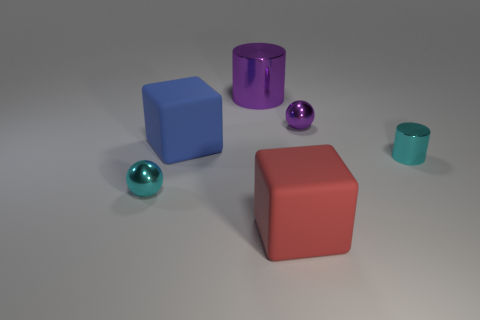There is a small shiny ball behind the cyan ball; is it the same color as the large shiny cylinder?
Your answer should be compact. Yes. There is a small metal cylinder; does it have the same color as the metal thing that is left of the big blue rubber block?
Offer a very short reply. Yes. Is there anything else that has the same color as the tiny cylinder?
Give a very brief answer. Yes. How many purple balls are to the left of the metal object that is in front of the cyan object to the right of the tiny purple metal sphere?
Provide a short and direct response. 0. Are there the same number of large red objects that are on the right side of the tiny purple metal thing and cyan metallic objects that are in front of the cyan shiny cylinder?
Your answer should be compact. No. What number of red things are the same shape as the blue matte object?
Ensure brevity in your answer.  1. Are there any large cylinders made of the same material as the tiny purple thing?
Provide a short and direct response. Yes. What is the shape of the tiny metallic thing that is the same color as the small cylinder?
Offer a terse response. Sphere. How many cylinders are there?
Provide a succinct answer. 2. How many cylinders are either small metal objects or tiny purple metallic objects?
Keep it short and to the point. 1. 